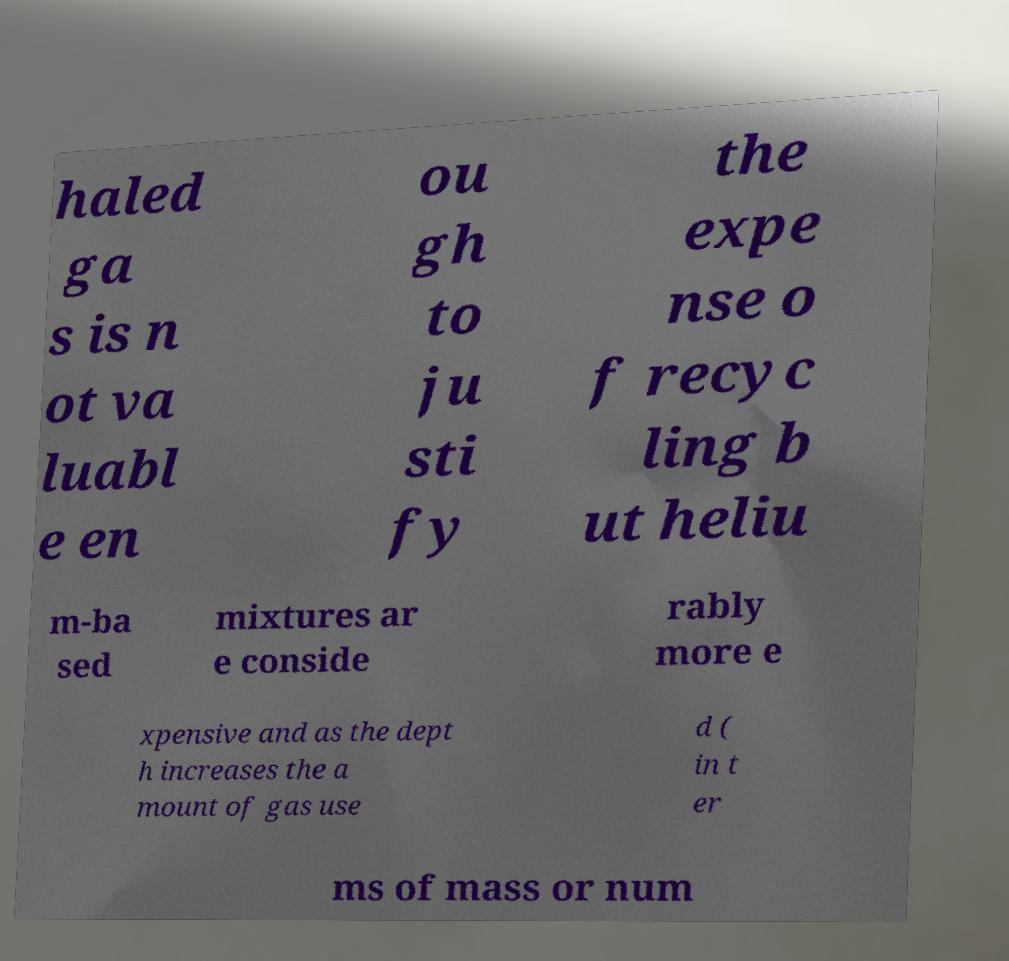Please read and relay the text visible in this image. What does it say? haled ga s is n ot va luabl e en ou gh to ju sti fy the expe nse o f recyc ling b ut heliu m-ba sed mixtures ar e conside rably more e xpensive and as the dept h increases the a mount of gas use d ( in t er ms of mass or num 